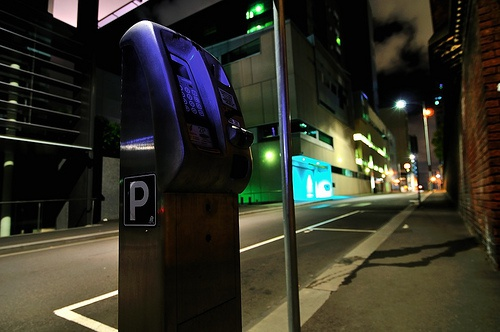Describe the objects in this image and their specific colors. I can see a parking meter in black, navy, darkblue, and blue tones in this image. 